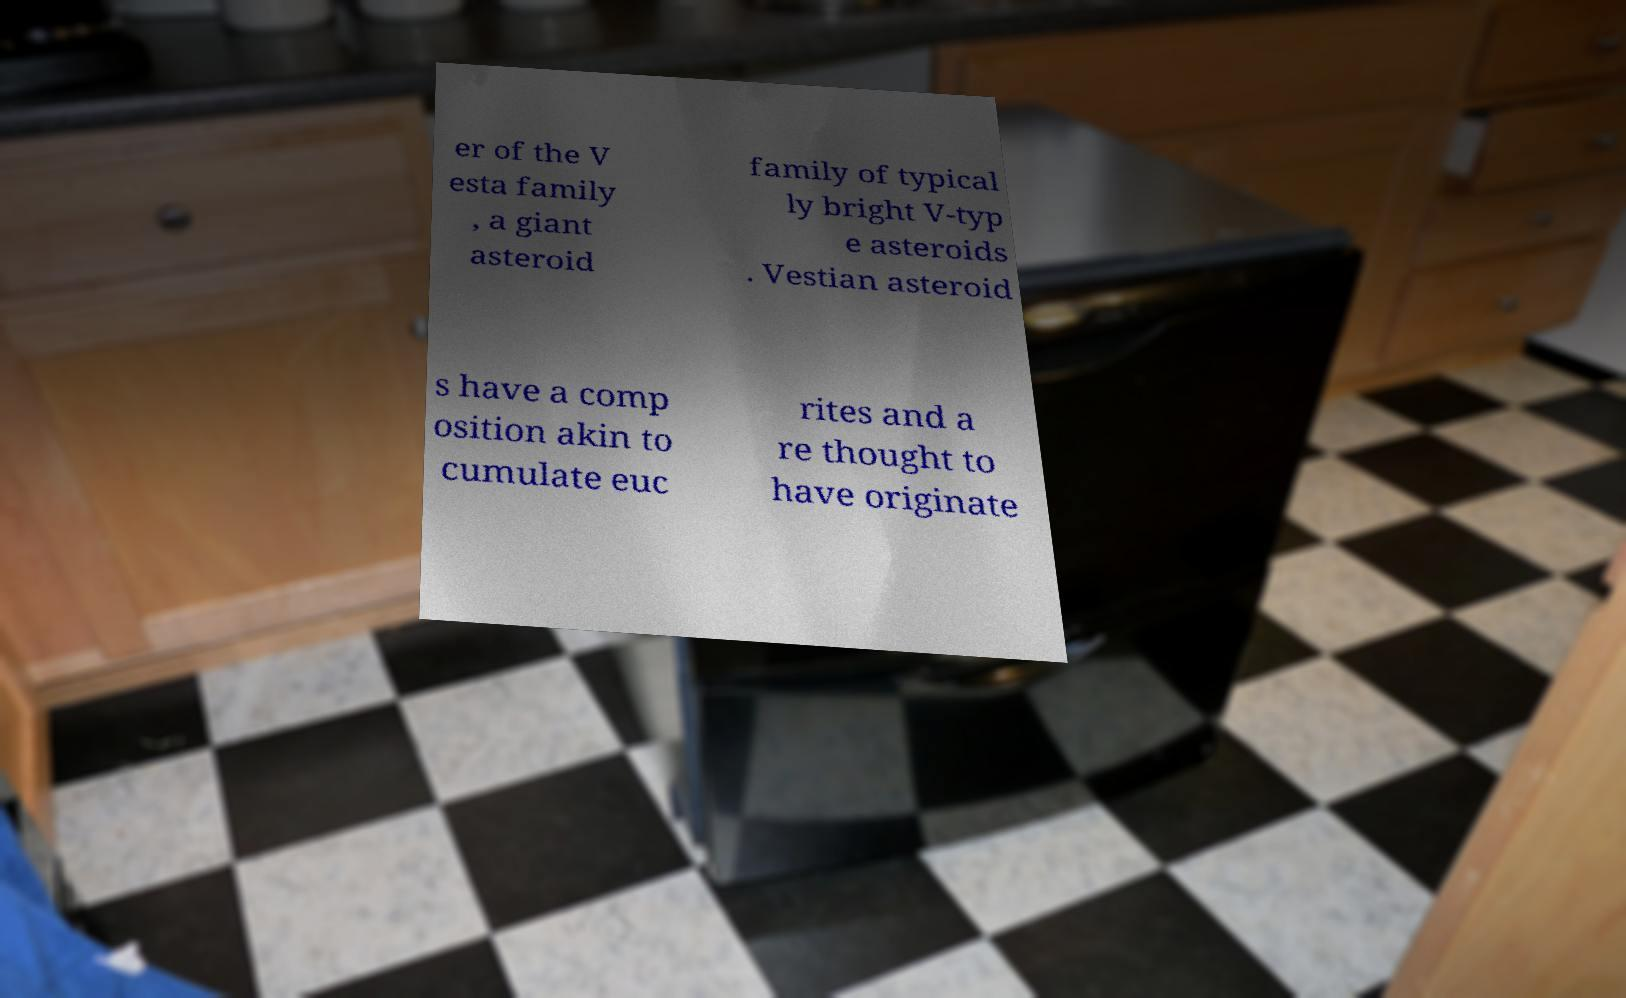Could you assist in decoding the text presented in this image and type it out clearly? er of the V esta family , a giant asteroid family of typical ly bright V-typ e asteroids . Vestian asteroid s have a comp osition akin to cumulate euc rites and a re thought to have originate 